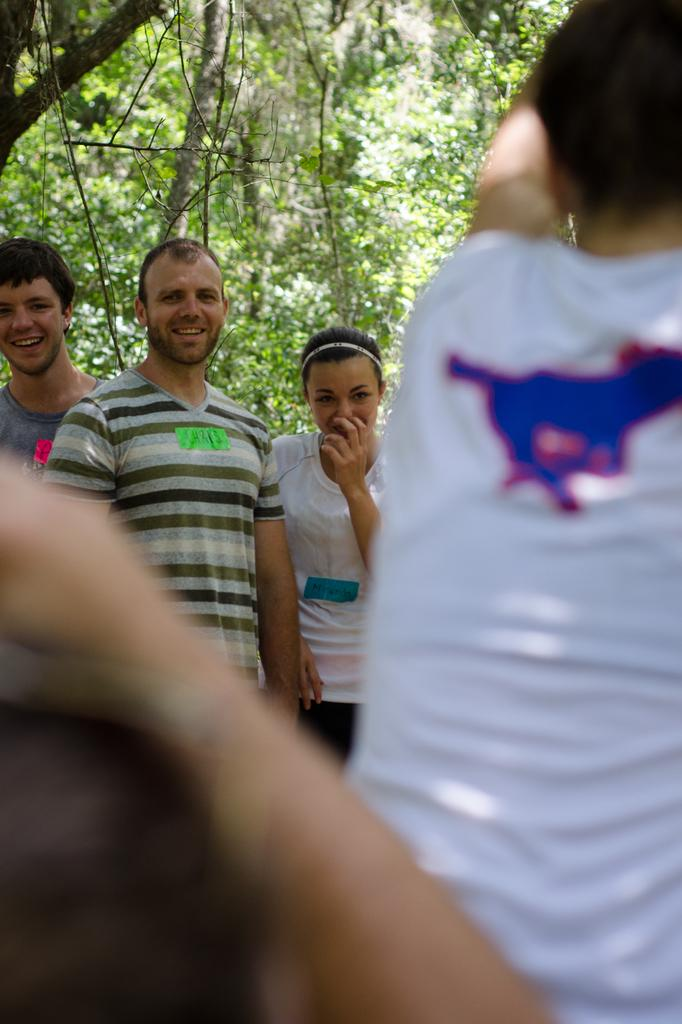Who or what can be seen in the image? There are people in the image. What can be seen in the distance behind the people? There are trees in the background of the image. What type of grape is growing on the stem in the image? There is no grape or stem present in the image. 